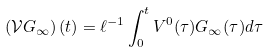<formula> <loc_0><loc_0><loc_500><loc_500>\left ( \mathcal { V } G _ { \infty } \right ) ( t ) = \ell ^ { - 1 } \int _ { 0 } ^ { t } V ^ { 0 } ( \tau ) G _ { \infty } ( \tau ) d \tau</formula> 